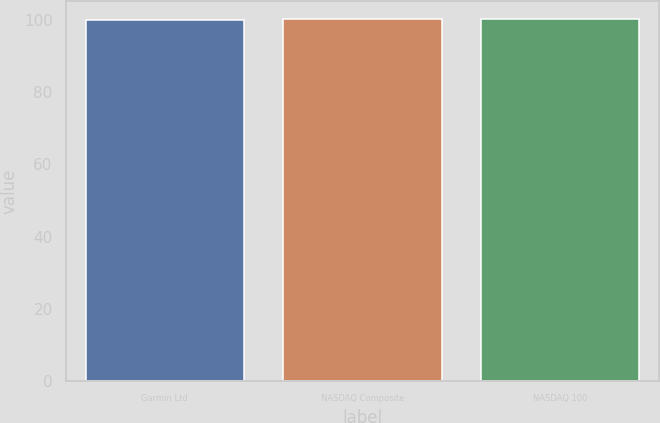<chart> <loc_0><loc_0><loc_500><loc_500><bar_chart><fcel>Garmin Ltd<fcel>NASDAQ Composite<fcel>NASDAQ 100<nl><fcel>100<fcel>100.1<fcel>100.2<nl></chart> 